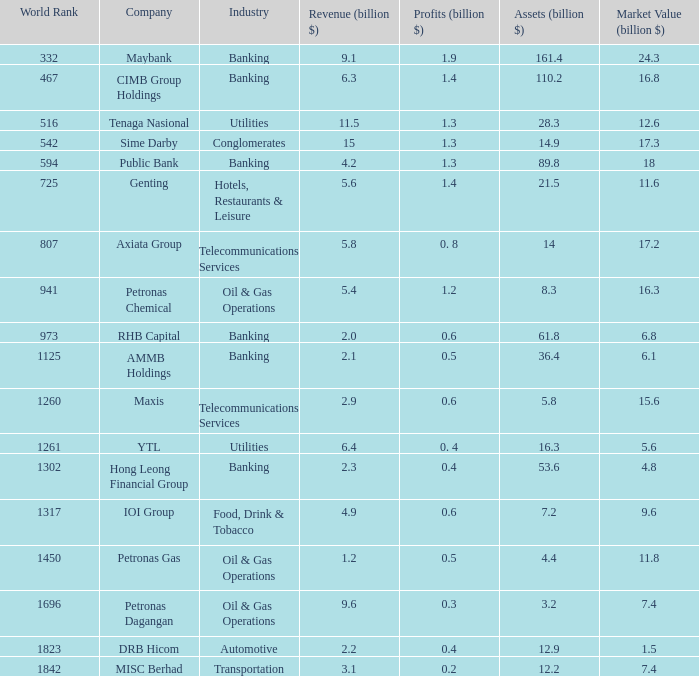Identify the sector with Banking. 